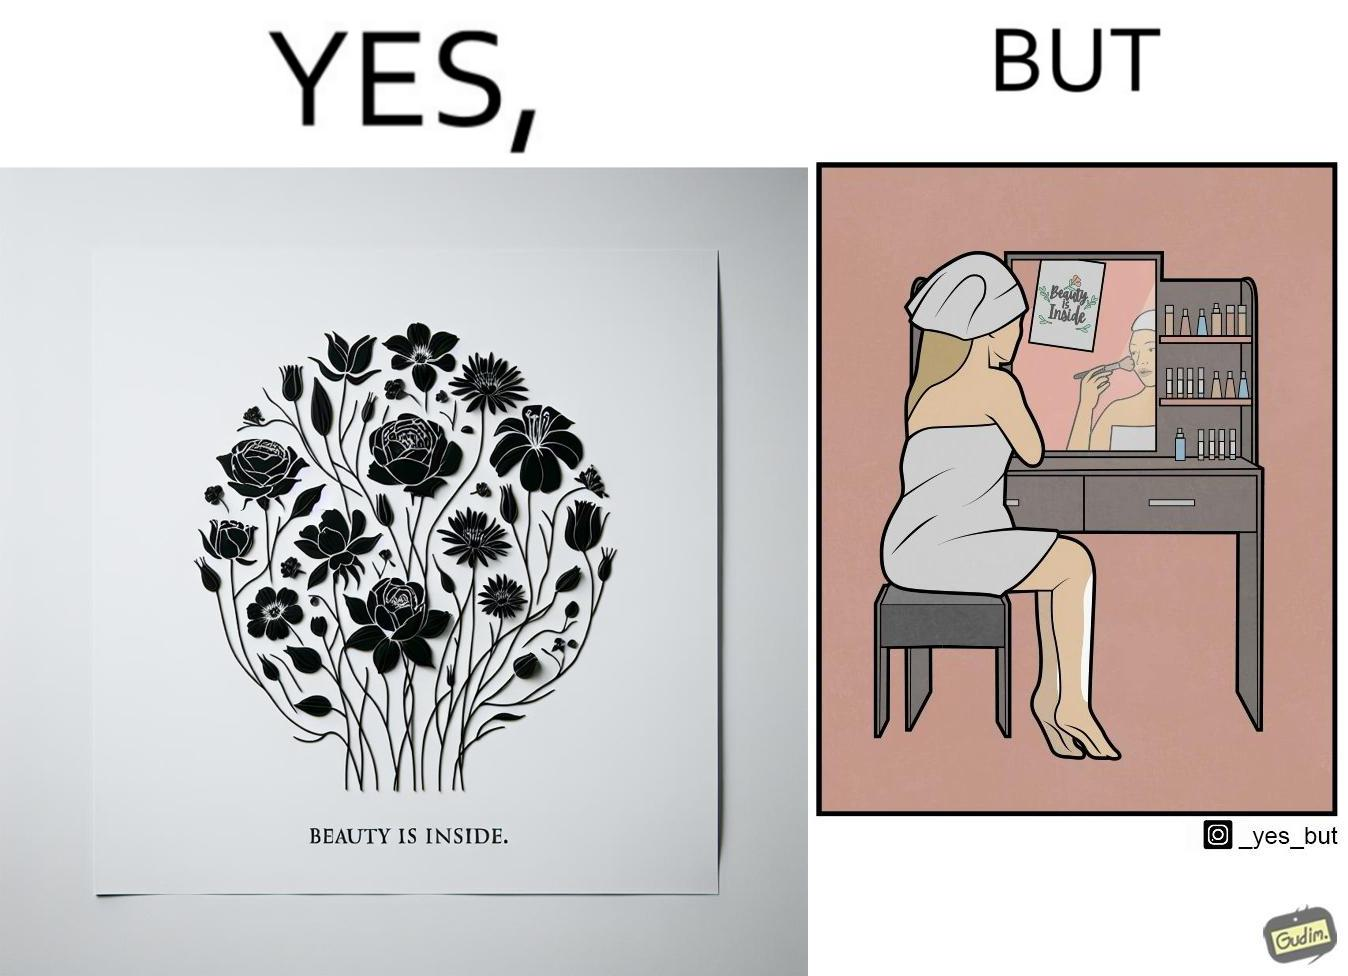Is there satirical content in this image? Yes, this image is satirical. 